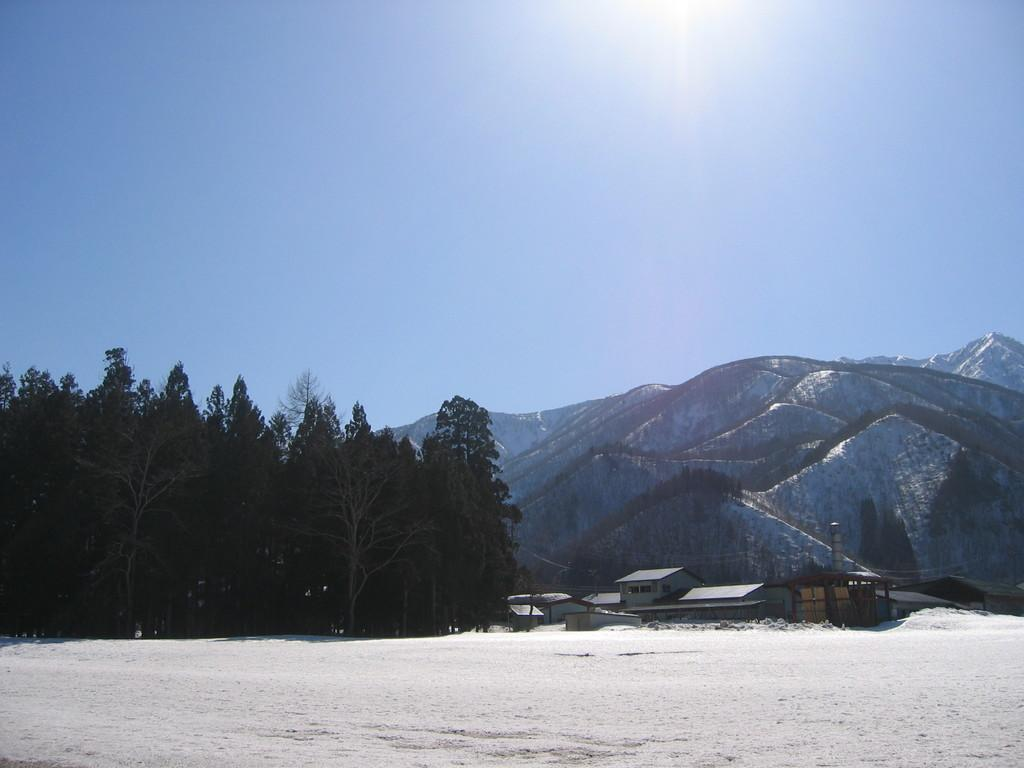What type of weather is depicted in the image? There is snow in the image, indicating cold weather. What type of vegetation can be seen in the image? Trees are present in the image. What type of structure is visible in the image? There is a building in the image. What can be seen in the distance in the image? Mountains are visible in the background of the image. What is visible above the mountains in the image? The sky is visible in the background of the image. What type of bubble can be seen floating in the image? There is no bubble present in the image. What type of rock formation can be seen in the image? There is no rock formation present in the image. 